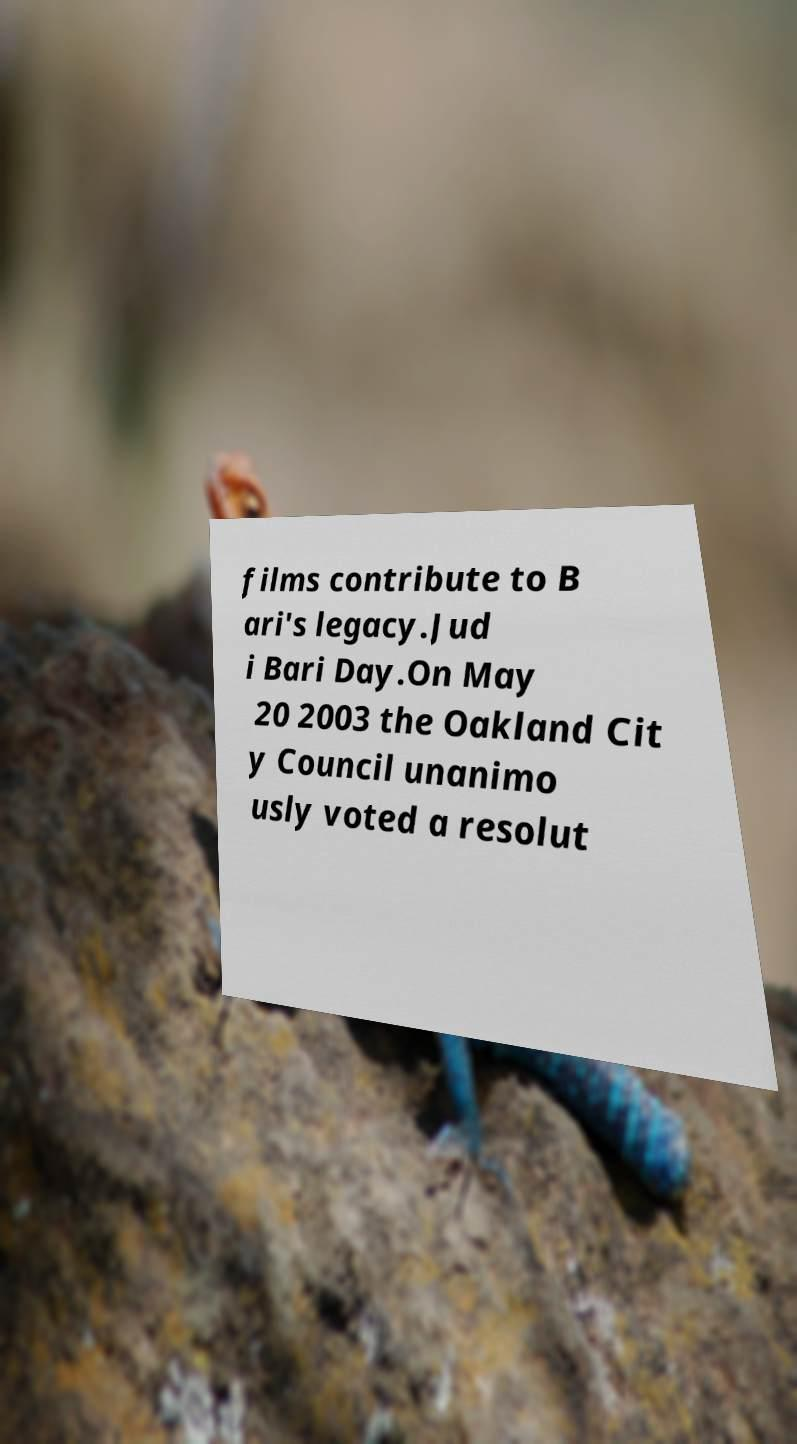For documentation purposes, I need the text within this image transcribed. Could you provide that? films contribute to B ari's legacy.Jud i Bari Day.On May 20 2003 the Oakland Cit y Council unanimo usly voted a resolut 